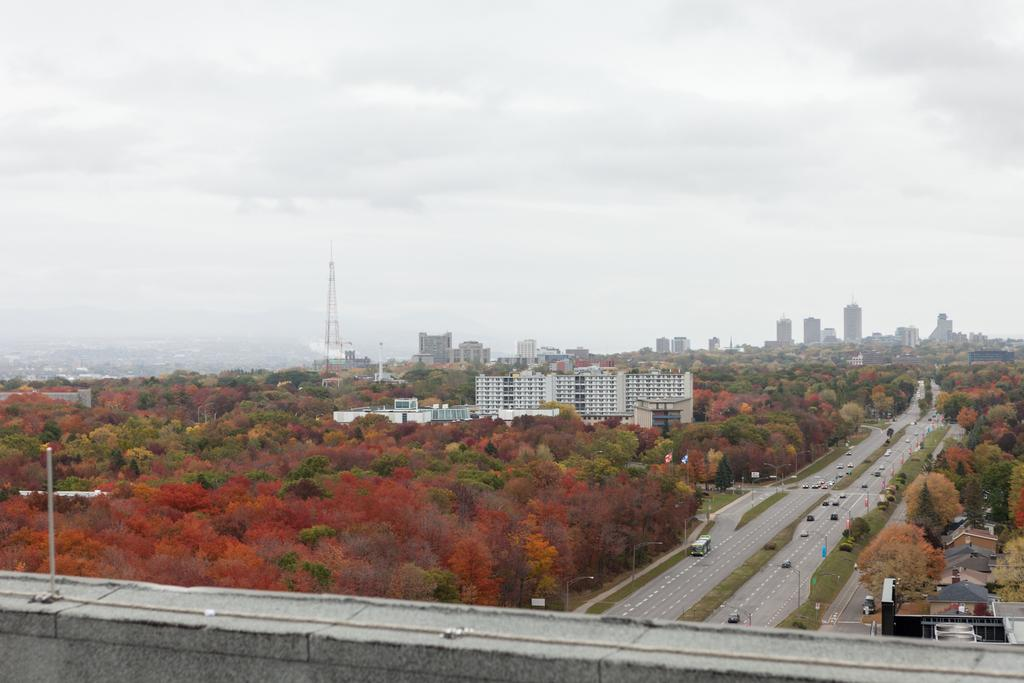What type of natural elements can be seen in the image? There are trees in the image. What man-made structures are visible in the image? There are vehicles, a road, street lights, houses, a building, and a tower in the image. What is the condition of the sky in the image? The sky is visible in the image, and clouds are present. What type of camp can be seen in the image? There is no camp present in the image. What observation can be made about the level of regret in the image? There is no indication of regret in the image, as it features various structures and natural elements. 